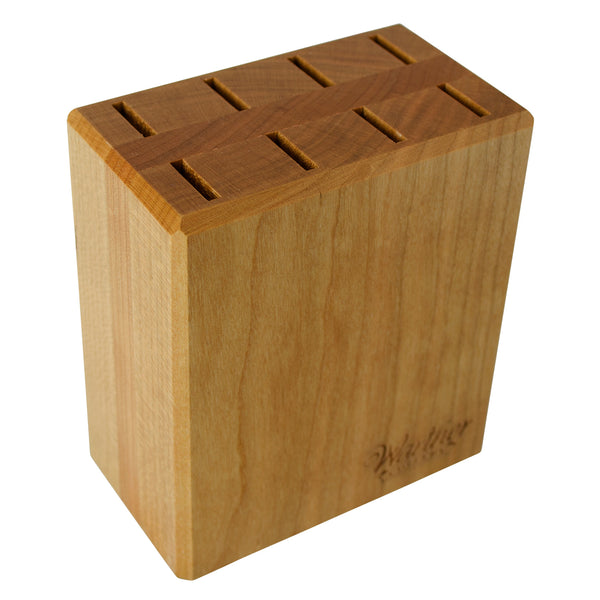Can this type of wooden knife holder be enhanced for better utility or is it considered optimal as is? While the current design is highly functional, enhancements can be made for even greater utility. For instance, adding a base with non-slip pads could improve stability, preventing the holder from sliding on slick surfaces. Integrating a magnetic strip could also offer a modern twist, allowing for the external secure holding of frequently used knives or metal kitchen tools. Additionally, treating the wood with eco-friendly water-resistant coatings would ensure a longer lifespan and easier cleaning. 